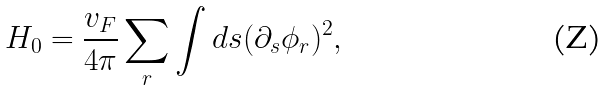Convert formula to latex. <formula><loc_0><loc_0><loc_500><loc_500>H _ { 0 } = \frac { v _ { F } } { 4 \pi } \sum _ { r } \int d s ( \partial _ { s } \phi _ { r } ) ^ { 2 } ,</formula> 